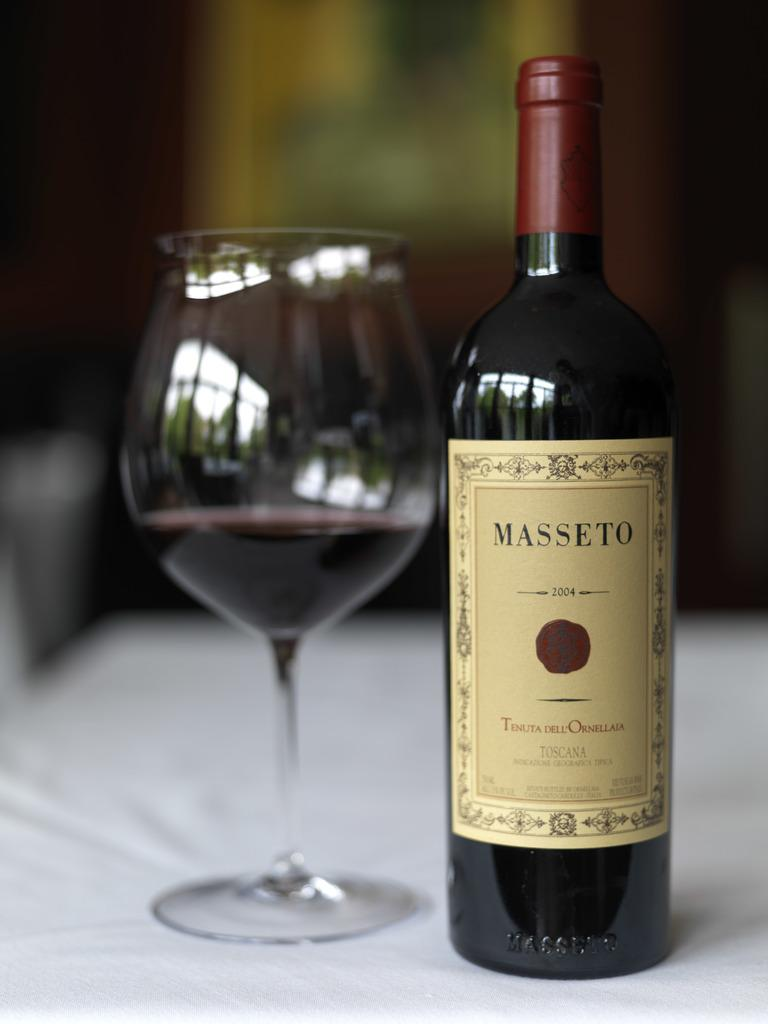Provide a one-sentence caption for the provided image. A bottle of Masseto Toscana is sitting on a table next to a wine glass. 